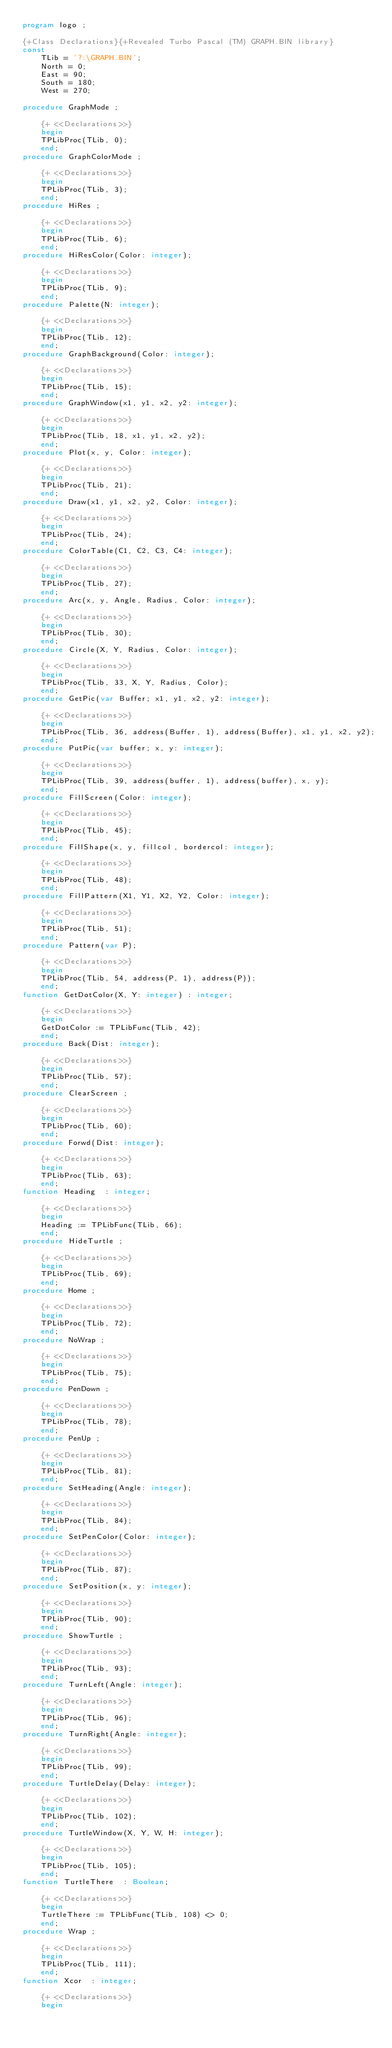<code> <loc_0><loc_0><loc_500><loc_500><_Pascal_>program logo ;

{+Class Declarations}{+Revealed Turbo Pascal (TM) GRAPH.BIN library}
const
	TLib = '?:\GRAPH.BIN';
	North = 0;
	East = 90;
	South = 180;
	West = 270;

procedure GraphMode ;
	
	{+ <<Declarations>>}
    begin
	TPLibProc(TLib, 0);
    end;
procedure GraphColorMode ;
	
	{+ <<Declarations>>}
    begin
	TPLibProc(TLib, 3);
    end;
procedure HiRes ;
	
	{+ <<Declarations>>}
    begin
	TPLibProc(TLib, 6);
    end;
procedure HiResColor(Color: integer);
	
	{+ <<Declarations>>}
    begin
	TPLibProc(TLib, 9);
    end;
procedure Palette(N: integer);
	
	{+ <<Declarations>>}
    begin
	TPLibProc(TLib, 12);
    end;
procedure GraphBackground(Color: integer);
	
	{+ <<Declarations>>}
    begin
	TPLibProc(TLib, 15);
    end;
procedure GraphWindow(x1, y1, x2, y2: integer);
	
	{+ <<Declarations>>}
    begin
	TPLibProc(TLib, 18, x1, y1, x2, y2);
    end;
procedure Plot(x, y, Color: integer);
	
	{+ <<Declarations>>}
    begin
	TPLibProc(TLib, 21);
    end;
procedure Draw(x1, y1, x2, y2, Color: integer);
	
	{+ <<Declarations>>}
    begin
	TPLibProc(TLib, 24);
    end;
procedure ColorTable(C1, C2, C3, C4: integer);
	
	{+ <<Declarations>>}
    begin
	TPLibProc(TLib, 27);
    end;
procedure Arc(x, y, Angle, Radius, Color: integer);
	
	{+ <<Declarations>>}
    begin
	TPLibProc(TLib, 30);
    end;
procedure Circle(X, Y, Radius, Color: integer);
	
	{+ <<Declarations>>}
    begin
	TPLibProc(TLib, 33, X, Y, Radius, Color);
    end;
procedure GetPic(var Buffer; x1, y1, x2, y2: integer);
	
	{+ <<Declarations>>}
    begin
	TPLibProc(TLib, 36, address(Buffer, 1), address(Buffer), x1, y1, x2, y2);
    end;
procedure PutPic(var buffer; x, y: integer);
	
	{+ <<Declarations>>}
    begin
	TPLibProc(TLib, 39, address(buffer, 1), address(buffer), x, y);
    end;
procedure FillScreen(Color: integer);
	
	{+ <<Declarations>>}
    begin
	TPLibProc(TLib, 45);
    end;
procedure FillShape(x, y, fillcol, bordercol: integer);
	
	{+ <<Declarations>>}
    begin
	TPLibProc(TLib, 48);
    end;
procedure FillPattern(X1, Y1, X2, Y2, Color: integer);
	
	{+ <<Declarations>>}
    begin
	TPLibProc(TLib, 51);
    end;
procedure Pattern(var P);
	
	{+ <<Declarations>>}
    begin
	TPLibProc(TLib, 54, address(P, 1), address(P));
    end;
function GetDotColor(X, Y: integer) : integer;
	
	{+ <<Declarations>>}
    begin
	GetDotColor := TPLibFunc(TLib, 42);
    end;
procedure Back(Dist: integer);
	
	{+ <<Declarations>>}
    begin
	TPLibProc(TLib, 57);
    end;
procedure ClearScreen ;
	
	{+ <<Declarations>>}
    begin
	TPLibProc(TLib, 60);
    end;
procedure Forwd(Dist: integer);
	
	{+ <<Declarations>>}
    begin
	TPLibProc(TLib, 63);
    end;
function Heading  : integer;
	
	{+ <<Declarations>>}
    begin
	Heading := TPLibFunc(TLib, 66);
    end;
procedure HideTurtle ;
	
	{+ <<Declarations>>}
    begin
	TPLibProc(TLib, 69);
    end;
procedure Home ;
	
	{+ <<Declarations>>}
    begin
	TPLibProc(TLib, 72);
    end;
procedure NoWrap ;
	
	{+ <<Declarations>>}
    begin
	TPLibProc(TLib, 75);
    end;
procedure PenDown ;
	
	{+ <<Declarations>>}
    begin
	TPLibProc(TLib, 78);
    end;
procedure PenUp ;
	
	{+ <<Declarations>>}
    begin
	TPLibProc(TLib, 81);
    end;
procedure SetHeading(Angle: integer);
	
	{+ <<Declarations>>}
    begin
	TPLibProc(TLib, 84);
    end;
procedure SetPenColor(Color: integer);
	
	{+ <<Declarations>>}
    begin
	TPLibProc(TLib, 87);
    end;
procedure SetPosition(x, y: integer);
	
	{+ <<Declarations>>}
    begin
	TPLibProc(TLib, 90);
    end;
procedure ShowTurtle ;
	
	{+ <<Declarations>>}
    begin
	TPLibProc(TLib, 93);
    end;
procedure TurnLeft(Angle: integer);
	
	{+ <<Declarations>>}
    begin
	TPLibProc(TLib, 96);
    end;
procedure TurnRight(Angle: integer);
	
	{+ <<Declarations>>}
    begin
	TPLibProc(TLib, 99);
    end;
procedure TurtleDelay(Delay: integer);
	
	{+ <<Declarations>>}
    begin
	TPLibProc(TLib, 102);
    end;
procedure TurtleWindow(X, Y, W, H: integer);
	
	{+ <<Declarations>>}
    begin
	TPLibProc(TLib, 105);
    end;
function TurtleThere  : Boolean;
	
	{+ <<Declarations>>}
    begin
	TurtleThere := TPLibFunc(TLib, 108) <> 0;
    end;
procedure Wrap ;
	
	{+ <<Declarations>>}
    begin
	TPLibProc(TLib, 111);
    end;
function Xcor  : integer;
	
	{+ <<Declarations>>}
    begin</code> 